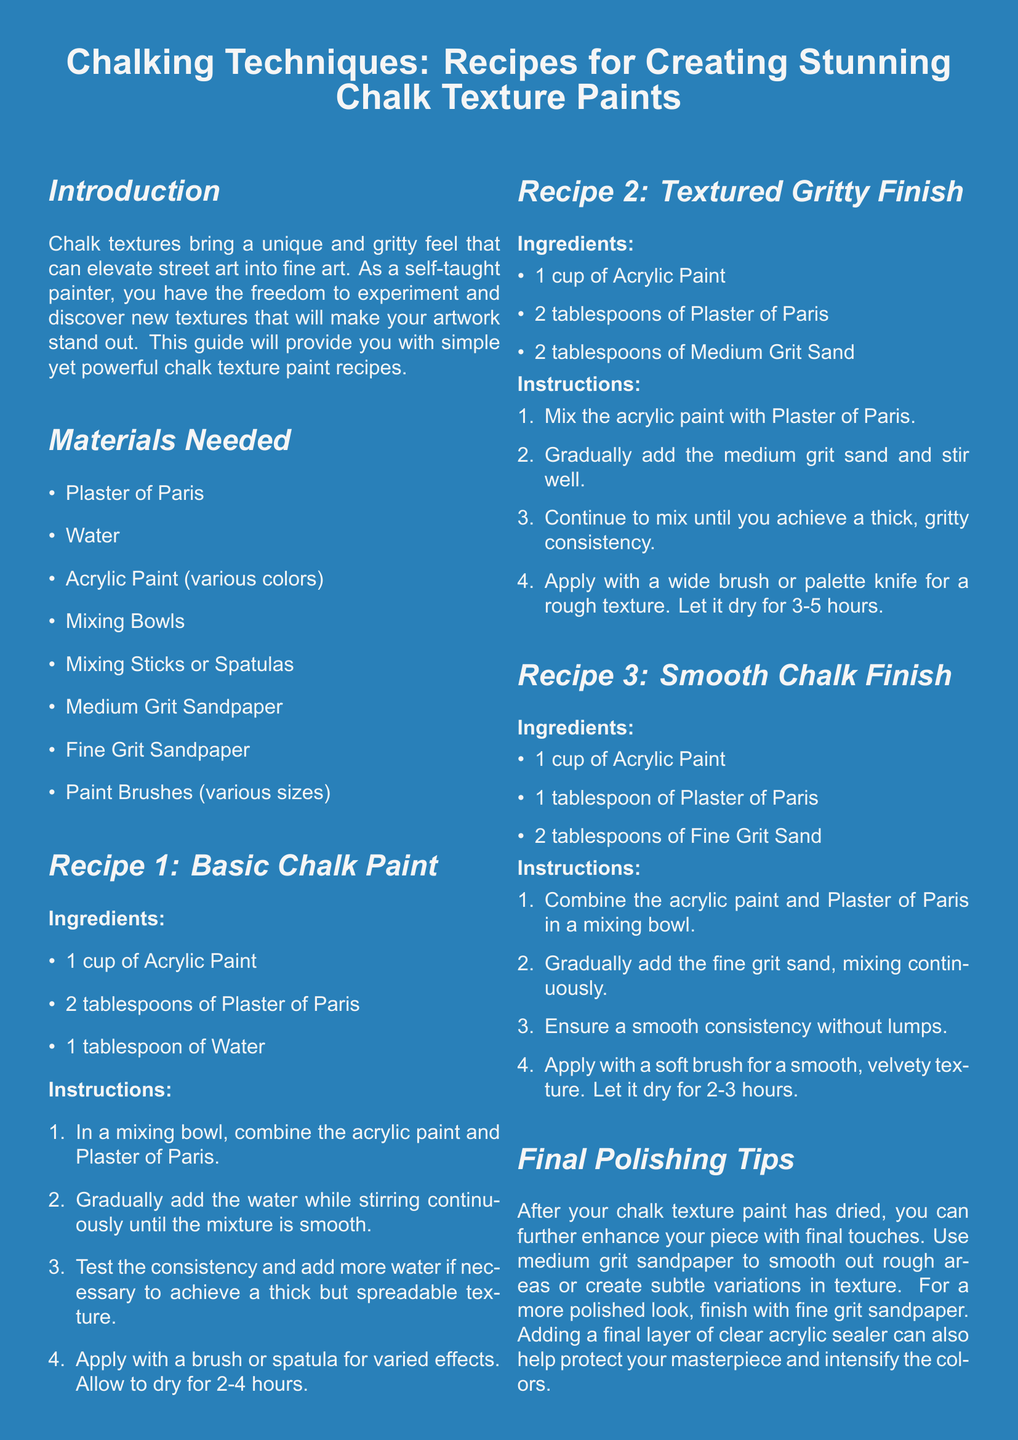What is the first recipe in the document? The first recipe is listed under "Recipe 1: Basic Chalk Paint" in the document.
Answer: Basic Chalk Paint How many tablespoons of Plaster of Paris are needed for the Textured Gritty Finish recipe? The Textured Gritty Finish recipe requires 2 tablespoons of Plaster of Paris, as stated in the ingredients list.
Answer: 2 tablespoons What is used to achieve a smooth consistency in the Smooth Chalk Finish? The document states that fine grit sand is used in the Smooth Chalk Finish to achieve a smooth consistency.
Answer: Fine Grit Sand How long should the Basic Chalk Paint dry? According to the instructions for the Basic Chalk Paint, it should dry for 2-4 hours.
Answer: 2-4 hours What type of texture does the final polishing tips refer to? The final polishing tips mention smoothing rough areas or creating variations in texture, indicating that the focus is on texture.
Answer: Texture 